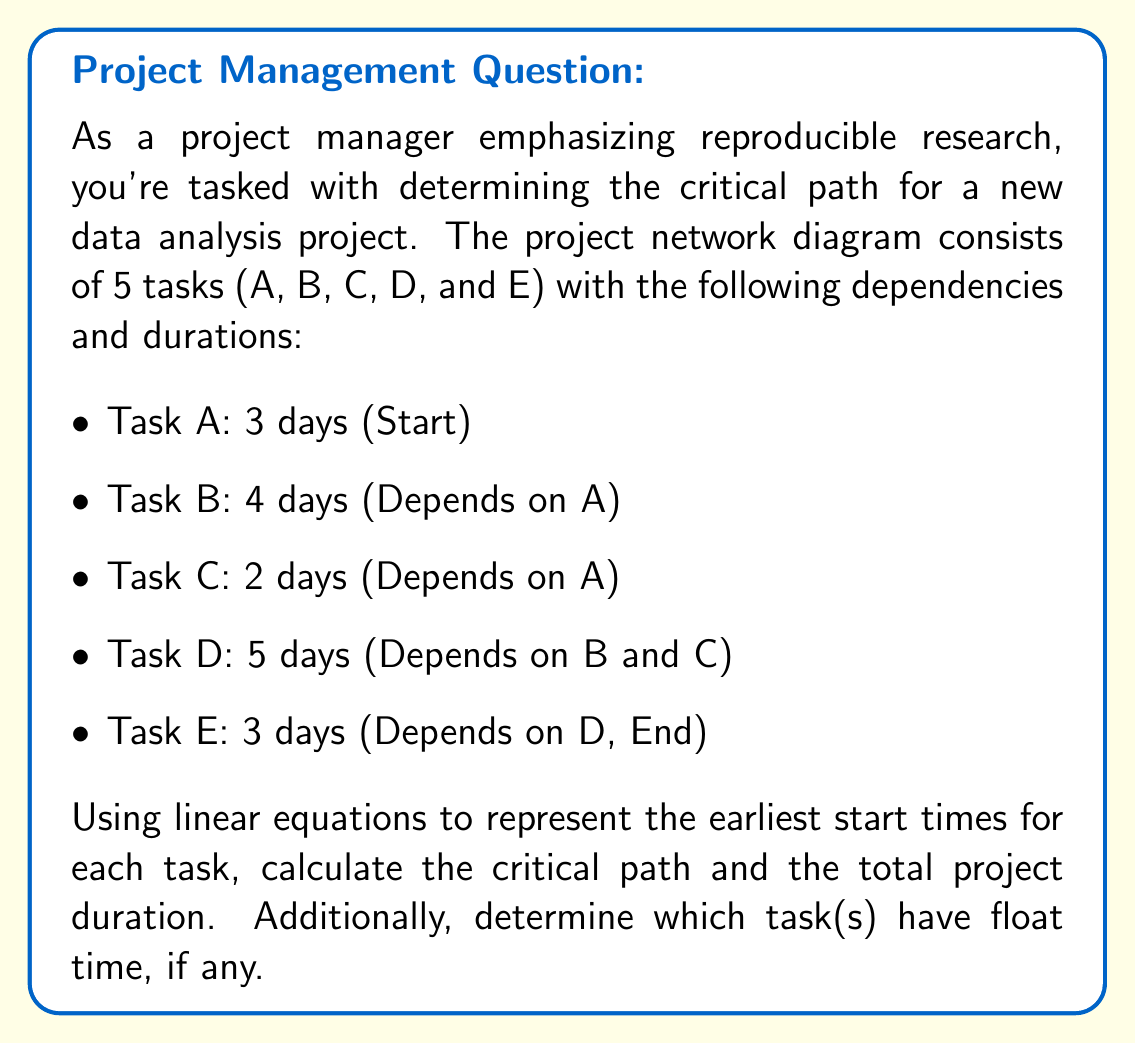Can you solve this math problem? To solve this problem, we'll use linear equations to represent the earliest start times for each task and then determine the critical path.

1. Define variables:
   Let $x_A$, $x_B$, $x_C$, $x_D$, and $x_E$ be the earliest start times for tasks A, B, C, D, and E, respectively.

2. Set up linear equations:
   $$x_A = 0$$ (Task A starts at the beginning)
   $$x_B \geq x_A + 3$$ (Task B starts after A is complete)
   $$x_C \geq x_A + 3$$ (Task C starts after A is complete)
   $$x_D \geq x_B + 4$$ (Task D starts after B is complete)
   $$x_D \geq x_C + 2$$ (Task D starts after C is complete)
   $$x_E \geq x_D + 5$$ (Task E starts after D is complete)

3. Solve the equations:
   $$x_A = 0$$
   $$x_B = 3$$
   $$x_C = 3$$
   $$x_D = \max(3+4, 3+2) = \max(7, 5) = 7$$
   $$x_E = 7 + 5 = 12$$

4. Calculate the earliest finish times:
   - A: 0 + 3 = 3
   - B: 3 + 4 = 7
   - C: 3 + 2 = 5
   - D: 7 + 5 = 12
   - E: 12 + 3 = 15

5. Determine the critical path:
   The critical path is the longest path through the network, which is A → B → D → E.

6. Calculate float times:
   - Task A: 0 (on critical path)
   - Task B: 0 (on critical path)
   - Task C: 7 - 5 = 2 days of float
   - Task D: 0 (on critical path)
   - Task E: 0 (on critical path)

The total project duration is 15 days, which is the earliest finish time of the last task (E).
Answer: The critical path is A → B → D → E, with a total project duration of 15 days. Task C has 2 days of float time, while all other tasks are on the critical path with 0 float time. 